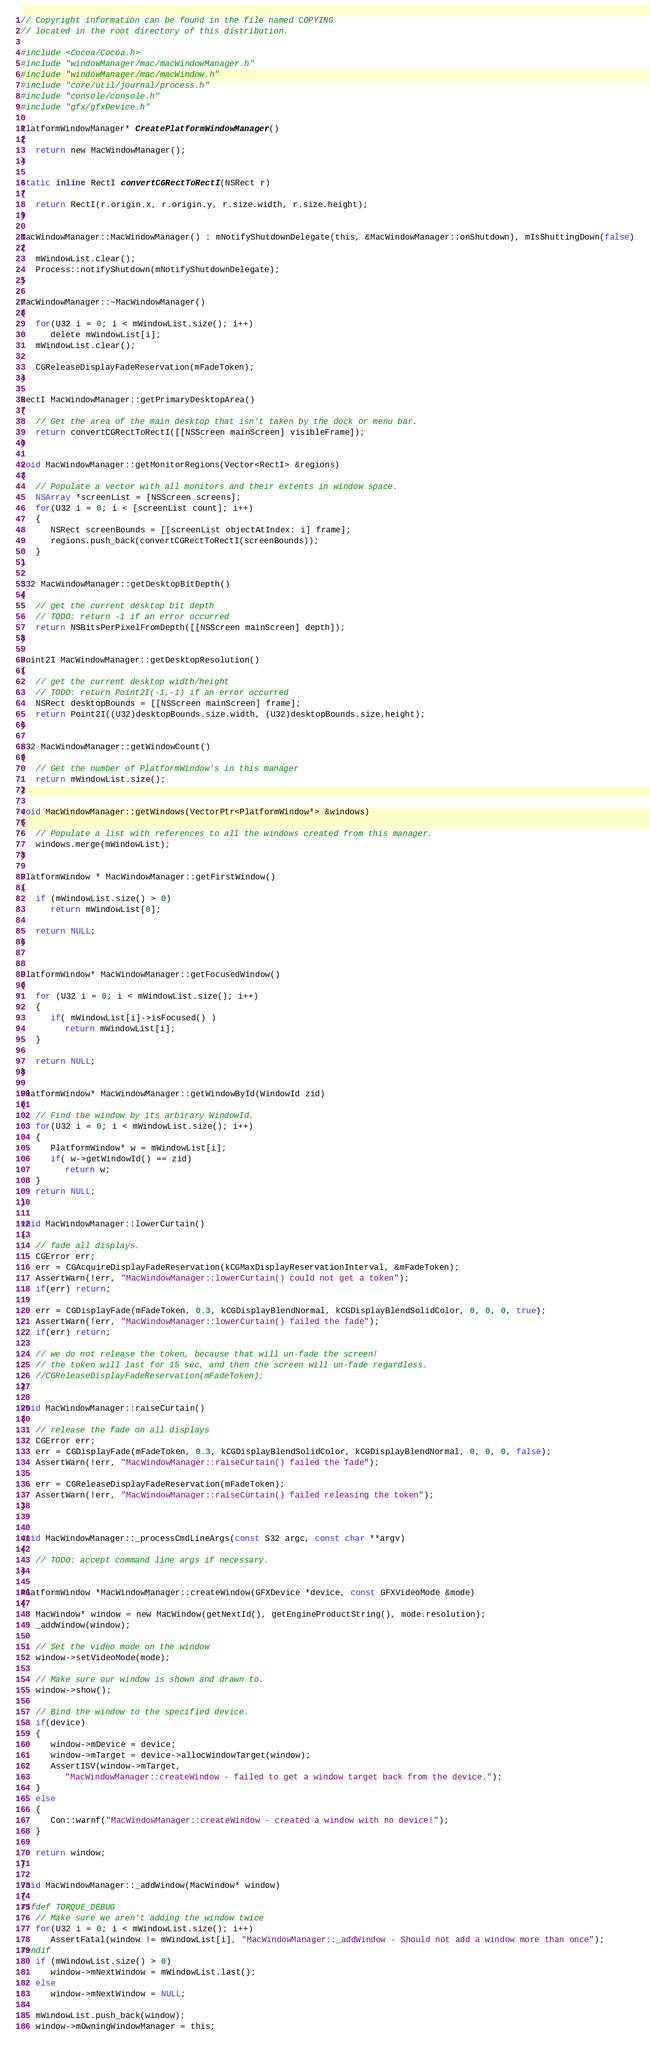<code> <loc_0><loc_0><loc_500><loc_500><_ObjectiveC_>// Copyright information can be found in the file named COPYING
// located in the root directory of this distribution.

#include <Cocoa/Cocoa.h>
#include "windowManager/mac/macWindowManager.h"
#include "windowManager/mac/macWindow.h"
#include "core/util/journal/process.h"
#include "console/console.h"
#include "gfx/gfxDevice.h"

PlatformWindowManager* CreatePlatformWindowManager()
{
   return new MacWindowManager();
}

static inline RectI convertCGRectToRectI(NSRect r)
{
   return RectI(r.origin.x, r.origin.y, r.size.width, r.size.height);
}

MacWindowManager::MacWindowManager() : mNotifyShutdownDelegate(this, &MacWindowManager::onShutdown), mIsShuttingDown(false)
{
   mWindowList.clear();
   Process::notifyShutdown(mNotifyShutdownDelegate);
}

MacWindowManager::~MacWindowManager()
{  
   for(U32 i = 0; i < mWindowList.size(); i++)
      delete mWindowList[i];
   mWindowList.clear();
   
   CGReleaseDisplayFadeReservation(mFadeToken);
}

RectI MacWindowManager::getPrimaryDesktopArea()
{
   // Get the area of the main desktop that isn't taken by the dock or menu bar.
   return convertCGRectToRectI([[NSScreen mainScreen] visibleFrame]);
}

void MacWindowManager::getMonitorRegions(Vector<RectI> &regions)
{
   // Populate a vector with all monitors and their extents in window space.
   NSArray *screenList = [NSScreen screens];
   for(U32 i = 0; i < [screenList count]; i++)
   {
      NSRect screenBounds = [[screenList objectAtIndex: i] frame];
      regions.push_back(convertCGRectToRectI(screenBounds));
   }
}

S32 MacWindowManager::getDesktopBitDepth()
{
   // get the current desktop bit depth
   // TODO: return -1 if an error occurred
   return NSBitsPerPixelFromDepth([[NSScreen mainScreen] depth]);
}

Point2I MacWindowManager::getDesktopResolution()
{
   // get the current desktop width/height
   // TODO: return Point2I(-1,-1) if an error occurred
   NSRect desktopBounds = [[NSScreen mainScreen] frame];
   return Point2I((U32)desktopBounds.size.width, (U32)desktopBounds.size.height);
}

S32 MacWindowManager::getWindowCount()
{
   // Get the number of PlatformWindow's in this manager
   return mWindowList.size();
}

void MacWindowManager::getWindows(VectorPtr<PlatformWindow*> &windows)
{
   // Populate a list with references to all the windows created from this manager.
   windows.merge(mWindowList);
}

PlatformWindow * MacWindowManager::getFirstWindow()
{
   if (mWindowList.size() > 0)
      return mWindowList[0];
      
   return NULL;
}


PlatformWindow* MacWindowManager::getFocusedWindow()
{
   for (U32 i = 0; i < mWindowList.size(); i++)
   {
      if( mWindowList[i]->isFocused() )
         return mWindowList[i];
   }

   return NULL;
}

PlatformWindow* MacWindowManager::getWindowById(WindowId zid)
{
   // Find the window by its arbirary WindowId.
   for(U32 i = 0; i < mWindowList.size(); i++)
   {
      PlatformWindow* w = mWindowList[i];
      if( w->getWindowId() == zid)
         return w;
   }
   return NULL;
}

void MacWindowManager::lowerCurtain()
{
   // fade all displays.
   CGError err;
   err = CGAcquireDisplayFadeReservation(kCGMaxDisplayReservationInterval, &mFadeToken);
   AssertWarn(!err, "MacWindowManager::lowerCurtain() could not get a token");
   if(err) return;
   
   err = CGDisplayFade(mFadeToken, 0.3, kCGDisplayBlendNormal, kCGDisplayBlendSolidColor, 0, 0, 0, true);
   AssertWarn(!err, "MacWindowManager::lowerCurtain() failed the fade");
   if(err) return;
   
   // we do not release the token, because that will un-fade the screen!
   // the token will last for 15 sec, and then the screen will un-fade regardless.
   //CGReleaseDisplayFadeReservation(mFadeToken);
}

void MacWindowManager::raiseCurtain()
{
   // release the fade on all displays
   CGError err;
   err = CGDisplayFade(mFadeToken, 0.3, kCGDisplayBlendSolidColor, kCGDisplayBlendNormal, 0, 0, 0, false);
   AssertWarn(!err, "MacWindowManager::raiseCurtain() failed the fade");
   
   err = CGReleaseDisplayFadeReservation(mFadeToken);
   AssertWarn(!err, "MacWindowManager::raiseCurtain() failed releasing the token");
}


void MacWindowManager::_processCmdLineArgs(const S32 argc, const char **argv)
{
   // TODO: accept command line args if necessary.
}

PlatformWindow *MacWindowManager::createWindow(GFXDevice *device, const GFXVideoMode &mode)
{
   MacWindow* window = new MacWindow(getNextId(), getEngineProductString(), mode.resolution);
   _addWindow(window);
   
   // Set the video mode on the window
   window->setVideoMode(mode);

   // Make sure our window is shown and drawn to.
   window->show();

   // Bind the window to the specified device.
   if(device)
   {
      window->mDevice = device;
      window->mTarget = device->allocWindowTarget(window);
      AssertISV(window->mTarget, 
         "MacWindowManager::createWindow - failed to get a window target back from the device.");
   }
   else
   {
      Con::warnf("MacWindowManager::createWindow - created a window with no device!");
   }

   return window;
}

void MacWindowManager::_addWindow(MacWindow* window)
{
#ifdef TORQUE_DEBUG
   // Make sure we aren't adding the window twice
   for(U32 i = 0; i < mWindowList.size(); i++)
      AssertFatal(window != mWindowList[i], "MacWindowManager::_addWindow - Should not add a window more than once");
#endif
   if (mWindowList.size() > 0)
      window->mNextWindow = mWindowList.last();
   else
      window->mNextWindow = NULL;

   mWindowList.push_back(window);
   window->mOwningWindowManager = this;</code> 